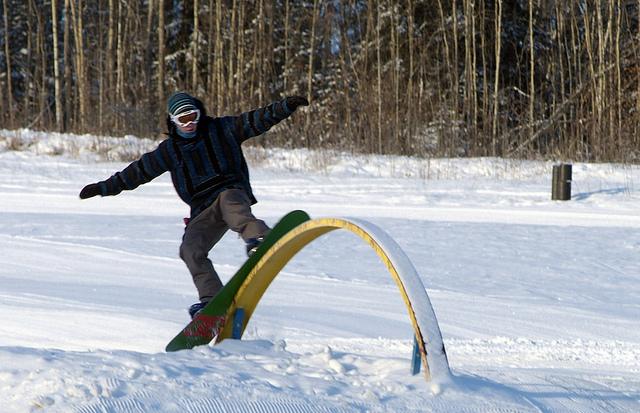What are the googles protecting?
Quick response, please. Eyes. Is that a man made jump?
Short answer required. Yes. What color is the bottom of the board?
Short answer required. Green. 